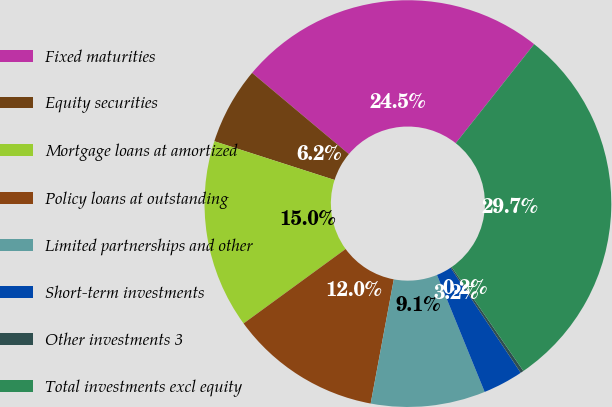<chart> <loc_0><loc_0><loc_500><loc_500><pie_chart><fcel>Fixed maturities<fcel>Equity securities<fcel>Mortgage loans at amortized<fcel>Policy loans at outstanding<fcel>Limited partnerships and other<fcel>Short-term investments<fcel>Other investments 3<fcel>Total investments excl equity<nl><fcel>24.55%<fcel>6.15%<fcel>14.99%<fcel>12.04%<fcel>9.09%<fcel>3.2%<fcel>0.25%<fcel>29.73%<nl></chart> 